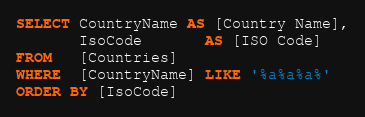<code> <loc_0><loc_0><loc_500><loc_500><_SQL_>SELECT CountryName AS [Country Name],
       IsoCode	   AS [ISO Code]
FROM   [Countries]
WHERE  [CountryName] LIKE '%a%a%a%'
ORDER BY [IsoCode]</code> 